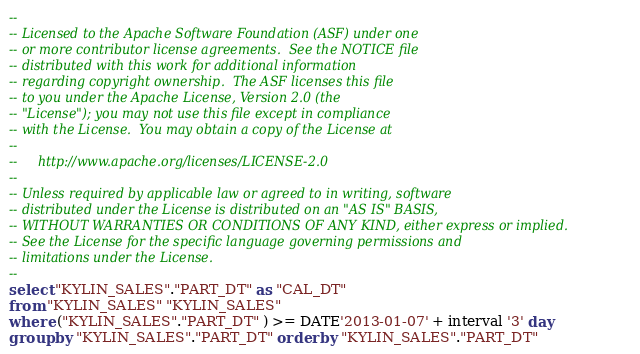Convert code to text. <code><loc_0><loc_0><loc_500><loc_500><_SQL_>--
-- Licensed to the Apache Software Foundation (ASF) under one
-- or more contributor license agreements.  See the NOTICE file
-- distributed with this work for additional information
-- regarding copyright ownership.  The ASF licenses this file
-- to you under the Apache License, Version 2.0 (the
-- "License"); you may not use this file except in compliance
-- with the License.  You may obtain a copy of the License at
--
--     http://www.apache.org/licenses/LICENSE-2.0
--
-- Unless required by applicable law or agreed to in writing, software
-- distributed under the License is distributed on an "AS IS" BASIS,
-- WITHOUT WARRANTIES OR CONDITIONS OF ANY KIND, either express or implied.
-- See the License for the specific language governing permissions and
-- limitations under the License.
--
select "KYLIN_SALES"."PART_DT" as "CAL_DT"
from "KYLIN_SALES" "KYLIN_SALES"
where ("KYLIN_SALES"."PART_DT" ) >= DATE'2013-01-07' + interval '3' day
group by "KYLIN_SALES"."PART_DT" order by "KYLIN_SALES"."PART_DT"</code> 